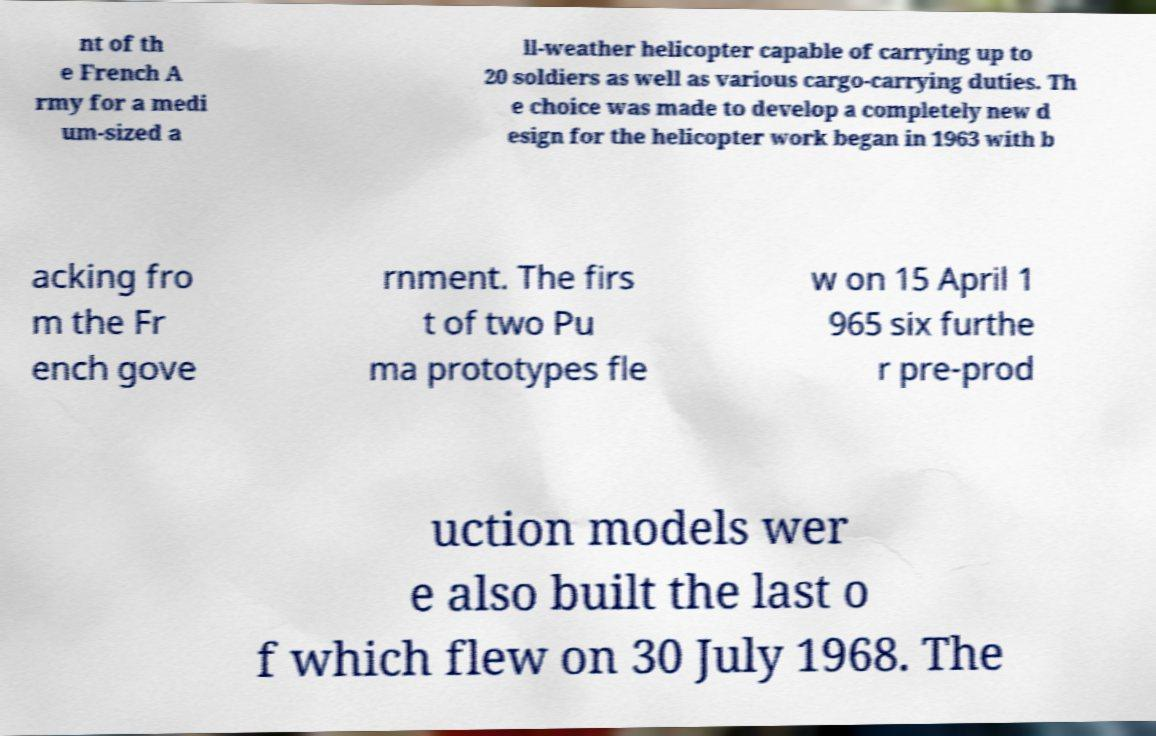What messages or text are displayed in this image? I need them in a readable, typed format. nt of th e French A rmy for a medi um-sized a ll-weather helicopter capable of carrying up to 20 soldiers as well as various cargo-carrying duties. Th e choice was made to develop a completely new d esign for the helicopter work began in 1963 with b acking fro m the Fr ench gove rnment. The firs t of two Pu ma prototypes fle w on 15 April 1 965 six furthe r pre-prod uction models wer e also built the last o f which flew on 30 July 1968. The 